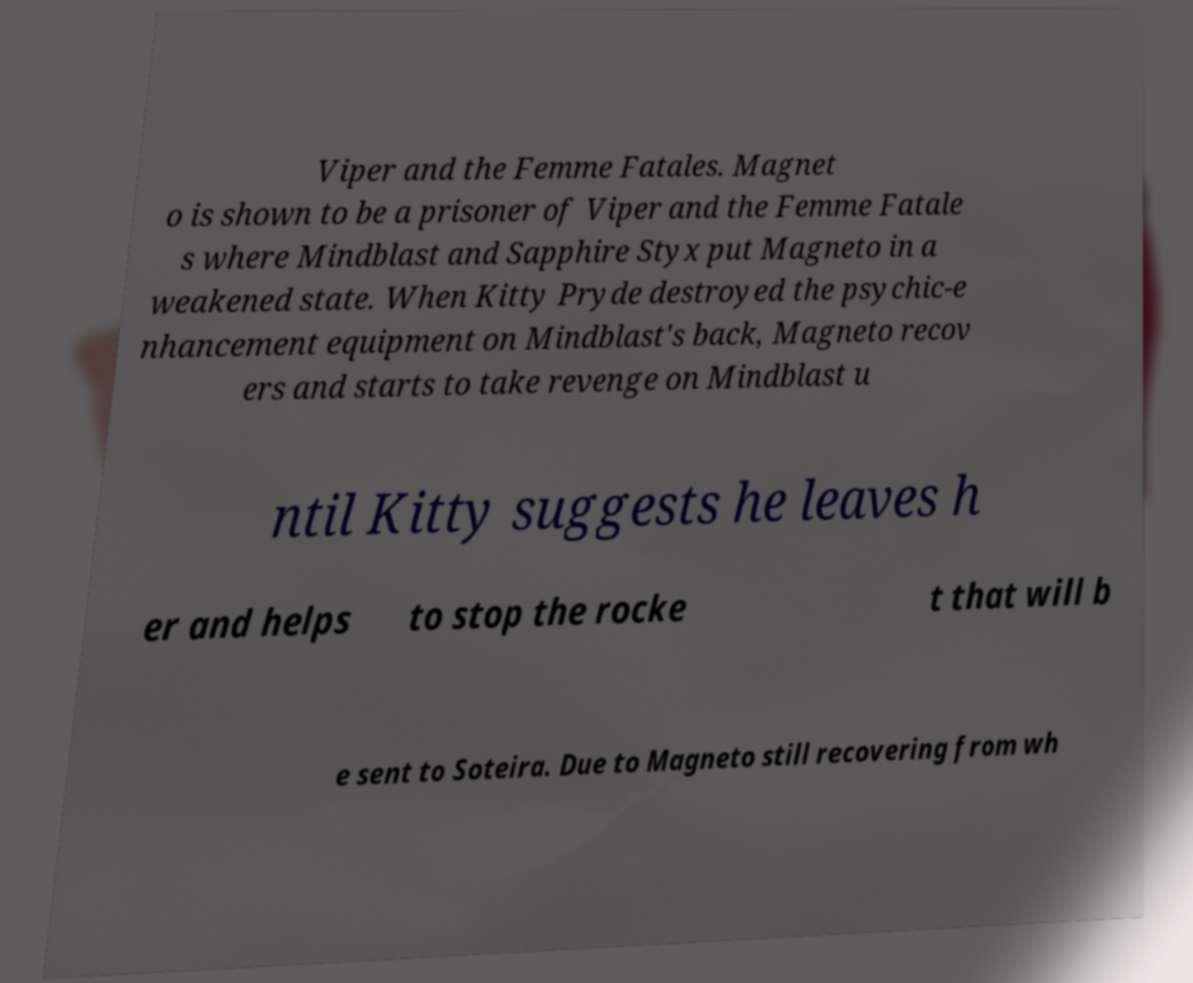There's text embedded in this image that I need extracted. Can you transcribe it verbatim? Viper and the Femme Fatales. Magnet o is shown to be a prisoner of Viper and the Femme Fatale s where Mindblast and Sapphire Styx put Magneto in a weakened state. When Kitty Pryde destroyed the psychic-e nhancement equipment on Mindblast's back, Magneto recov ers and starts to take revenge on Mindblast u ntil Kitty suggests he leaves h er and helps to stop the rocke t that will b e sent to Soteira. Due to Magneto still recovering from wh 